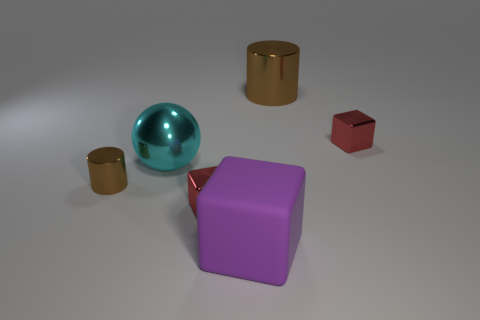Subtract all large matte cubes. How many cubes are left? 2 Add 3 tiny metal cubes. How many objects exist? 9 Subtract all purple cubes. How many cubes are left? 2 Subtract all shiny things. Subtract all spheres. How many objects are left? 0 Add 3 big brown cylinders. How many big brown cylinders are left? 4 Add 1 big gray balls. How many big gray balls exist? 1 Subtract 0 gray cubes. How many objects are left? 6 Subtract all cylinders. How many objects are left? 4 Subtract 2 blocks. How many blocks are left? 1 Subtract all red spheres. Subtract all blue blocks. How many spheres are left? 1 